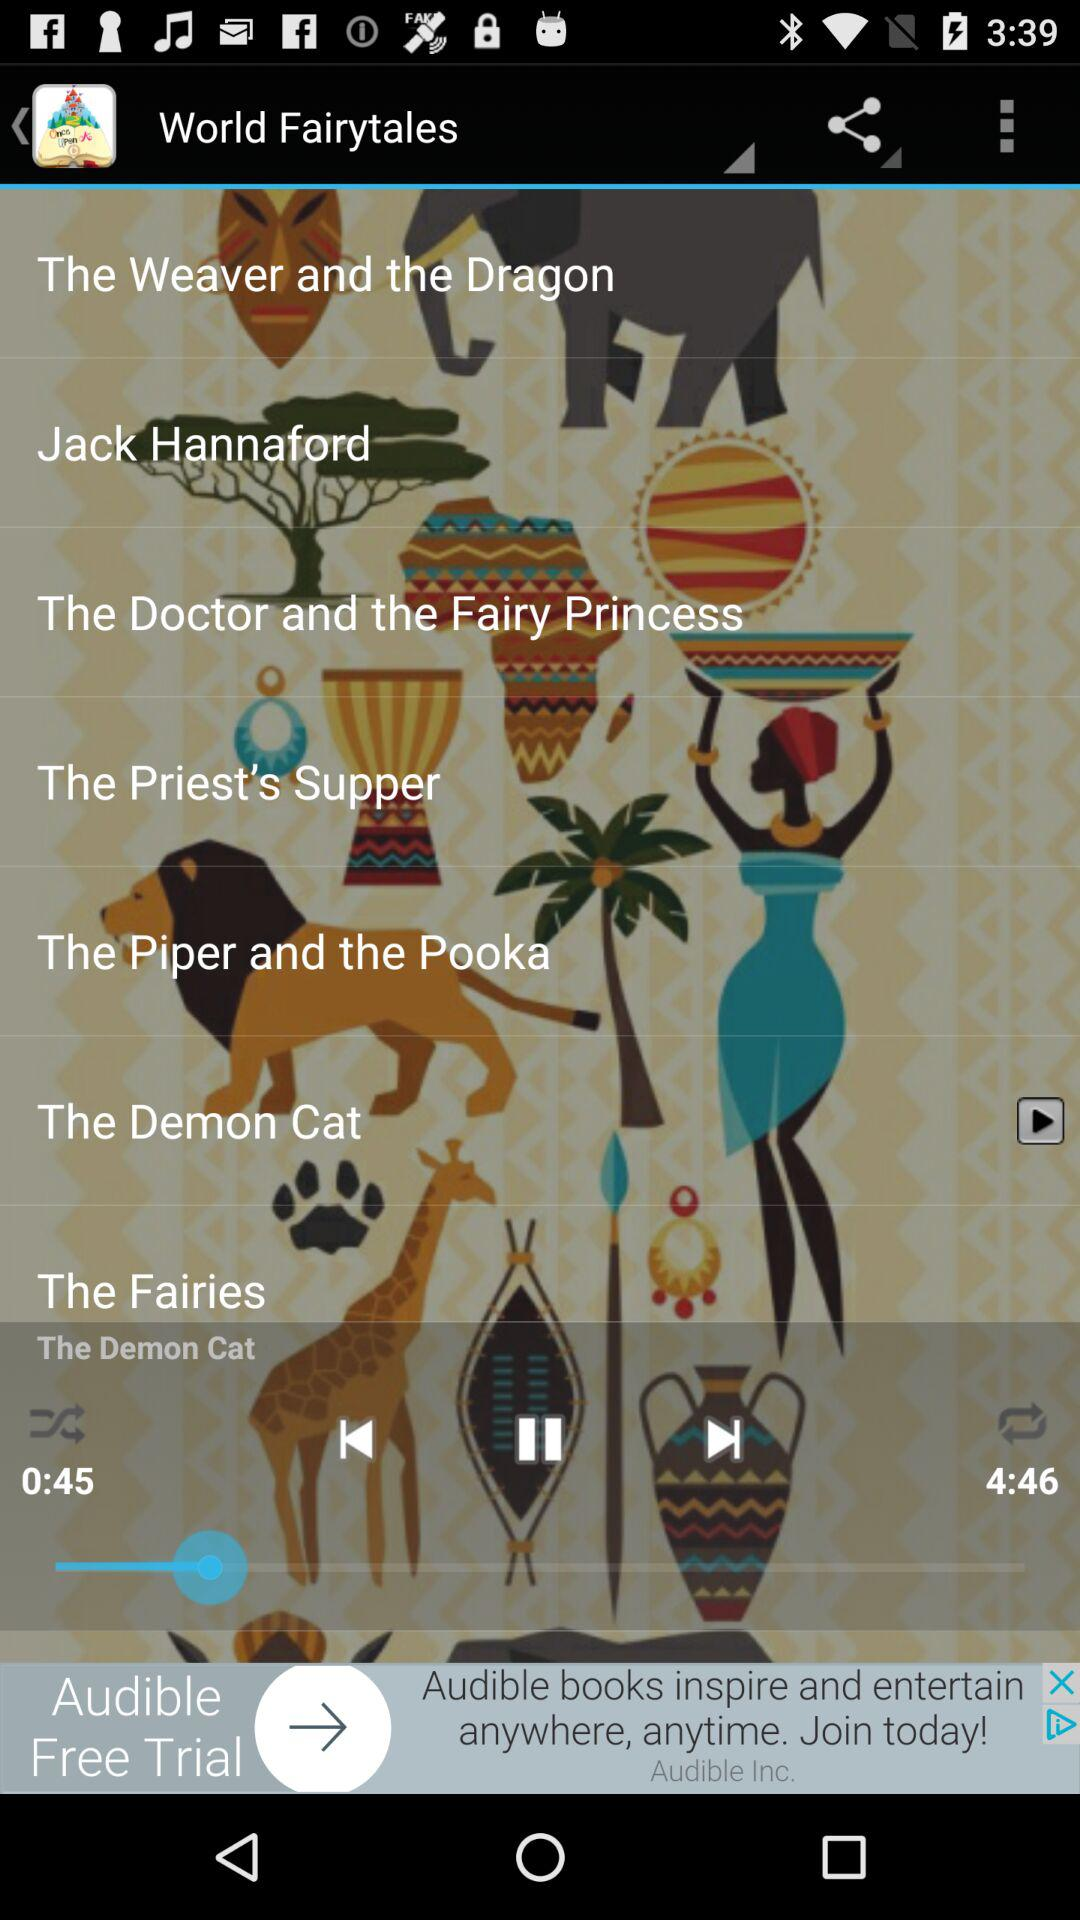Which audio is currently playing? The currently playing audio is "The Demon Cat". 